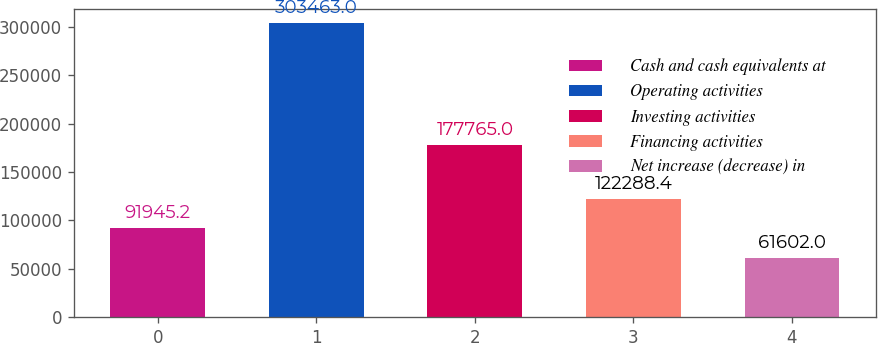Convert chart to OTSL. <chart><loc_0><loc_0><loc_500><loc_500><bar_chart><fcel>Cash and cash equivalents at<fcel>Operating activities<fcel>Investing activities<fcel>Financing activities<fcel>Net increase (decrease) in<nl><fcel>91945.2<fcel>303463<fcel>177765<fcel>122288<fcel>61602<nl></chart> 